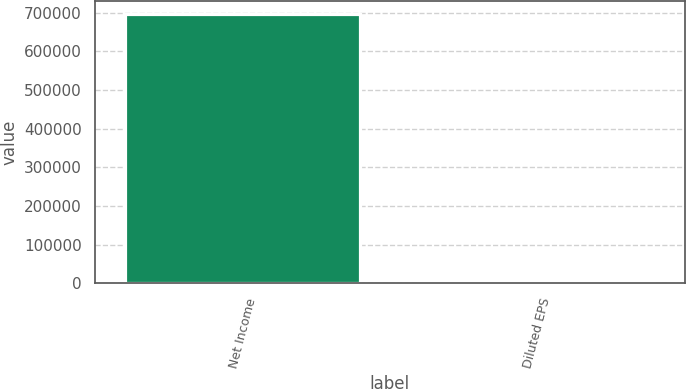Convert chart to OTSL. <chart><loc_0><loc_0><loc_500><loc_500><bar_chart><fcel>Net Income<fcel>Diluted EPS<nl><fcel>696878<fcel>2.2<nl></chart> 